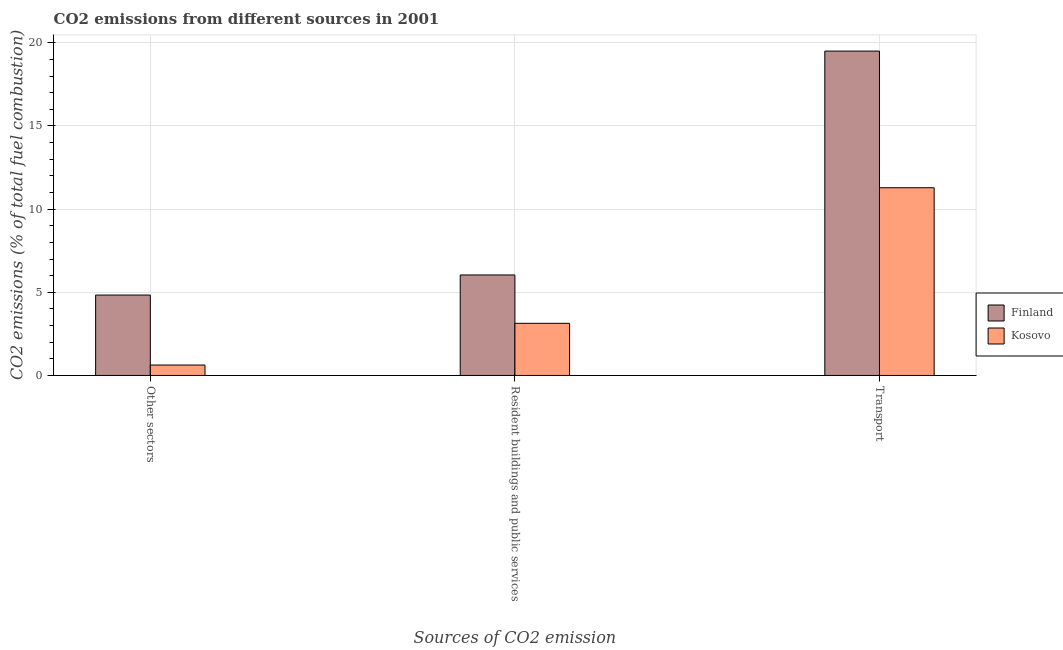How many groups of bars are there?
Provide a short and direct response. 3. Are the number of bars per tick equal to the number of legend labels?
Give a very brief answer. Yes. How many bars are there on the 1st tick from the left?
Your response must be concise. 2. How many bars are there on the 3rd tick from the right?
Offer a terse response. 2. What is the label of the 1st group of bars from the left?
Keep it short and to the point. Other sectors. What is the percentage of co2 emissions from other sectors in Finland?
Provide a short and direct response. 4.83. Across all countries, what is the maximum percentage of co2 emissions from resident buildings and public services?
Your answer should be compact. 6.04. Across all countries, what is the minimum percentage of co2 emissions from transport?
Your answer should be compact. 11.29. In which country was the percentage of co2 emissions from resident buildings and public services maximum?
Provide a succinct answer. Finland. In which country was the percentage of co2 emissions from transport minimum?
Offer a terse response. Kosovo. What is the total percentage of co2 emissions from resident buildings and public services in the graph?
Offer a terse response. 9.18. What is the difference between the percentage of co2 emissions from transport in Kosovo and that in Finland?
Ensure brevity in your answer.  -8.21. What is the difference between the percentage of co2 emissions from resident buildings and public services in Finland and the percentage of co2 emissions from other sectors in Kosovo?
Your answer should be very brief. 5.42. What is the average percentage of co2 emissions from other sectors per country?
Make the answer very short. 2.73. What is the difference between the percentage of co2 emissions from other sectors and percentage of co2 emissions from transport in Kosovo?
Give a very brief answer. -10.66. What is the ratio of the percentage of co2 emissions from transport in Kosovo to that in Finland?
Provide a succinct answer. 0.58. Is the percentage of co2 emissions from resident buildings and public services in Finland less than that in Kosovo?
Offer a very short reply. No. Is the difference between the percentage of co2 emissions from transport in Kosovo and Finland greater than the difference between the percentage of co2 emissions from other sectors in Kosovo and Finland?
Your answer should be compact. No. What is the difference between the highest and the second highest percentage of co2 emissions from transport?
Ensure brevity in your answer.  8.21. What is the difference between the highest and the lowest percentage of co2 emissions from resident buildings and public services?
Provide a short and direct response. 2.91. In how many countries, is the percentage of co2 emissions from other sectors greater than the average percentage of co2 emissions from other sectors taken over all countries?
Give a very brief answer. 1. Is the sum of the percentage of co2 emissions from transport in Kosovo and Finland greater than the maximum percentage of co2 emissions from other sectors across all countries?
Your answer should be compact. Yes. What does the 2nd bar from the left in Resident buildings and public services represents?
Ensure brevity in your answer.  Kosovo. Is it the case that in every country, the sum of the percentage of co2 emissions from other sectors and percentage of co2 emissions from resident buildings and public services is greater than the percentage of co2 emissions from transport?
Keep it short and to the point. No. How many bars are there?
Provide a succinct answer. 6. Are the values on the major ticks of Y-axis written in scientific E-notation?
Provide a short and direct response. No. Does the graph contain any zero values?
Your answer should be compact. No. Does the graph contain grids?
Make the answer very short. Yes. Where does the legend appear in the graph?
Provide a short and direct response. Center right. How are the legend labels stacked?
Your answer should be very brief. Vertical. What is the title of the graph?
Your answer should be compact. CO2 emissions from different sources in 2001. What is the label or title of the X-axis?
Make the answer very short. Sources of CO2 emission. What is the label or title of the Y-axis?
Give a very brief answer. CO2 emissions (% of total fuel combustion). What is the CO2 emissions (% of total fuel combustion) of Finland in Other sectors?
Offer a very short reply. 4.83. What is the CO2 emissions (% of total fuel combustion) in Kosovo in Other sectors?
Give a very brief answer. 0.63. What is the CO2 emissions (% of total fuel combustion) of Finland in Resident buildings and public services?
Offer a terse response. 6.04. What is the CO2 emissions (% of total fuel combustion) in Kosovo in Resident buildings and public services?
Your answer should be very brief. 3.13. What is the CO2 emissions (% of total fuel combustion) in Finland in Transport?
Your response must be concise. 19.5. What is the CO2 emissions (% of total fuel combustion) in Kosovo in Transport?
Provide a succinct answer. 11.29. Across all Sources of CO2 emission, what is the maximum CO2 emissions (% of total fuel combustion) of Finland?
Your answer should be compact. 19.5. Across all Sources of CO2 emission, what is the maximum CO2 emissions (% of total fuel combustion) of Kosovo?
Offer a very short reply. 11.29. Across all Sources of CO2 emission, what is the minimum CO2 emissions (% of total fuel combustion) in Finland?
Provide a succinct answer. 4.83. Across all Sources of CO2 emission, what is the minimum CO2 emissions (% of total fuel combustion) in Kosovo?
Give a very brief answer. 0.63. What is the total CO2 emissions (% of total fuel combustion) in Finland in the graph?
Your answer should be very brief. 30.38. What is the total CO2 emissions (% of total fuel combustion) in Kosovo in the graph?
Your response must be concise. 15.05. What is the difference between the CO2 emissions (% of total fuel combustion) of Finland in Other sectors and that in Resident buildings and public services?
Your answer should be very brief. -1.21. What is the difference between the CO2 emissions (% of total fuel combustion) in Kosovo in Other sectors and that in Resident buildings and public services?
Provide a succinct answer. -2.51. What is the difference between the CO2 emissions (% of total fuel combustion) of Finland in Other sectors and that in Transport?
Offer a very short reply. -14.67. What is the difference between the CO2 emissions (% of total fuel combustion) of Kosovo in Other sectors and that in Transport?
Your answer should be compact. -10.66. What is the difference between the CO2 emissions (% of total fuel combustion) in Finland in Resident buildings and public services and that in Transport?
Your answer should be very brief. -13.46. What is the difference between the CO2 emissions (% of total fuel combustion) of Kosovo in Resident buildings and public services and that in Transport?
Make the answer very short. -8.15. What is the difference between the CO2 emissions (% of total fuel combustion) of Finland in Other sectors and the CO2 emissions (% of total fuel combustion) of Kosovo in Resident buildings and public services?
Provide a succinct answer. 1.7. What is the difference between the CO2 emissions (% of total fuel combustion) in Finland in Other sectors and the CO2 emissions (% of total fuel combustion) in Kosovo in Transport?
Provide a short and direct response. -6.45. What is the difference between the CO2 emissions (% of total fuel combustion) of Finland in Resident buildings and public services and the CO2 emissions (% of total fuel combustion) of Kosovo in Transport?
Your answer should be very brief. -5.24. What is the average CO2 emissions (% of total fuel combustion) in Finland per Sources of CO2 emission?
Provide a short and direct response. 10.13. What is the average CO2 emissions (% of total fuel combustion) in Kosovo per Sources of CO2 emission?
Offer a very short reply. 5.02. What is the difference between the CO2 emissions (% of total fuel combustion) of Finland and CO2 emissions (% of total fuel combustion) of Kosovo in Other sectors?
Make the answer very short. 4.21. What is the difference between the CO2 emissions (% of total fuel combustion) of Finland and CO2 emissions (% of total fuel combustion) of Kosovo in Resident buildings and public services?
Ensure brevity in your answer.  2.91. What is the difference between the CO2 emissions (% of total fuel combustion) of Finland and CO2 emissions (% of total fuel combustion) of Kosovo in Transport?
Your response must be concise. 8.21. What is the ratio of the CO2 emissions (% of total fuel combustion) of Finland in Other sectors to that in Resident buildings and public services?
Ensure brevity in your answer.  0.8. What is the ratio of the CO2 emissions (% of total fuel combustion) of Kosovo in Other sectors to that in Resident buildings and public services?
Your answer should be very brief. 0.2. What is the ratio of the CO2 emissions (% of total fuel combustion) in Finland in Other sectors to that in Transport?
Offer a terse response. 0.25. What is the ratio of the CO2 emissions (% of total fuel combustion) of Kosovo in Other sectors to that in Transport?
Provide a succinct answer. 0.06. What is the ratio of the CO2 emissions (% of total fuel combustion) of Finland in Resident buildings and public services to that in Transport?
Your answer should be very brief. 0.31. What is the ratio of the CO2 emissions (% of total fuel combustion) of Kosovo in Resident buildings and public services to that in Transport?
Provide a short and direct response. 0.28. What is the difference between the highest and the second highest CO2 emissions (% of total fuel combustion) of Finland?
Provide a succinct answer. 13.46. What is the difference between the highest and the second highest CO2 emissions (% of total fuel combustion) in Kosovo?
Ensure brevity in your answer.  8.15. What is the difference between the highest and the lowest CO2 emissions (% of total fuel combustion) in Finland?
Your answer should be very brief. 14.67. What is the difference between the highest and the lowest CO2 emissions (% of total fuel combustion) in Kosovo?
Keep it short and to the point. 10.66. 